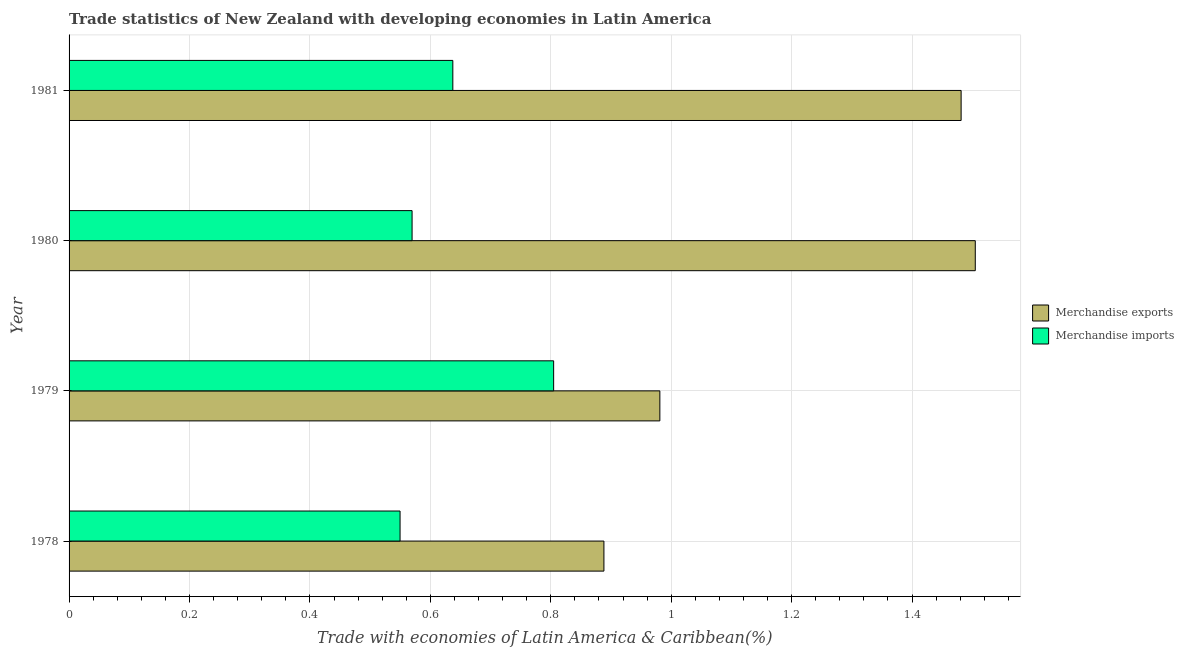Are the number of bars per tick equal to the number of legend labels?
Your response must be concise. Yes. How many bars are there on the 2nd tick from the bottom?
Provide a short and direct response. 2. What is the label of the 2nd group of bars from the top?
Your response must be concise. 1980. What is the merchandise imports in 1978?
Keep it short and to the point. 0.55. Across all years, what is the maximum merchandise imports?
Ensure brevity in your answer.  0.8. Across all years, what is the minimum merchandise imports?
Your answer should be very brief. 0.55. In which year was the merchandise exports maximum?
Ensure brevity in your answer.  1980. In which year was the merchandise imports minimum?
Your answer should be compact. 1978. What is the total merchandise imports in the graph?
Offer a very short reply. 2.56. What is the difference between the merchandise imports in 1978 and that in 1980?
Your answer should be compact. -0.02. What is the difference between the merchandise imports in 1979 and the merchandise exports in 1978?
Keep it short and to the point. -0.08. What is the average merchandise exports per year?
Ensure brevity in your answer.  1.21. In the year 1981, what is the difference between the merchandise exports and merchandise imports?
Provide a succinct answer. 0.84. What is the ratio of the merchandise imports in 1979 to that in 1981?
Offer a terse response. 1.26. Is the merchandise exports in 1978 less than that in 1981?
Give a very brief answer. Yes. Is the difference between the merchandise imports in 1978 and 1981 greater than the difference between the merchandise exports in 1978 and 1981?
Keep it short and to the point. Yes. What is the difference between the highest and the second highest merchandise imports?
Offer a terse response. 0.17. What is the difference between the highest and the lowest merchandise exports?
Your response must be concise. 0.62. What does the 1st bar from the top in 1980 represents?
Ensure brevity in your answer.  Merchandise imports. How many bars are there?
Your answer should be very brief. 8. Are all the bars in the graph horizontal?
Make the answer very short. Yes. How many years are there in the graph?
Your answer should be very brief. 4. What is the difference between two consecutive major ticks on the X-axis?
Provide a short and direct response. 0.2. Are the values on the major ticks of X-axis written in scientific E-notation?
Your answer should be very brief. No. Where does the legend appear in the graph?
Ensure brevity in your answer.  Center right. What is the title of the graph?
Give a very brief answer. Trade statistics of New Zealand with developing economies in Latin America. Does "GDP at market prices" appear as one of the legend labels in the graph?
Your answer should be very brief. No. What is the label or title of the X-axis?
Your response must be concise. Trade with economies of Latin America & Caribbean(%). What is the Trade with economies of Latin America & Caribbean(%) in Merchandise exports in 1978?
Your answer should be very brief. 0.89. What is the Trade with economies of Latin America & Caribbean(%) of Merchandise imports in 1978?
Ensure brevity in your answer.  0.55. What is the Trade with economies of Latin America & Caribbean(%) of Merchandise exports in 1979?
Offer a very short reply. 0.98. What is the Trade with economies of Latin America & Caribbean(%) in Merchandise imports in 1979?
Your answer should be very brief. 0.8. What is the Trade with economies of Latin America & Caribbean(%) of Merchandise exports in 1980?
Provide a succinct answer. 1.5. What is the Trade with economies of Latin America & Caribbean(%) of Merchandise imports in 1980?
Your response must be concise. 0.57. What is the Trade with economies of Latin America & Caribbean(%) of Merchandise exports in 1981?
Give a very brief answer. 1.48. What is the Trade with economies of Latin America & Caribbean(%) in Merchandise imports in 1981?
Make the answer very short. 0.64. Across all years, what is the maximum Trade with economies of Latin America & Caribbean(%) in Merchandise exports?
Give a very brief answer. 1.5. Across all years, what is the maximum Trade with economies of Latin America & Caribbean(%) in Merchandise imports?
Offer a terse response. 0.8. Across all years, what is the minimum Trade with economies of Latin America & Caribbean(%) of Merchandise exports?
Keep it short and to the point. 0.89. Across all years, what is the minimum Trade with economies of Latin America & Caribbean(%) of Merchandise imports?
Offer a very short reply. 0.55. What is the total Trade with economies of Latin America & Caribbean(%) in Merchandise exports in the graph?
Offer a terse response. 4.86. What is the total Trade with economies of Latin America & Caribbean(%) in Merchandise imports in the graph?
Give a very brief answer. 2.56. What is the difference between the Trade with economies of Latin America & Caribbean(%) of Merchandise exports in 1978 and that in 1979?
Offer a very short reply. -0.09. What is the difference between the Trade with economies of Latin America & Caribbean(%) of Merchandise imports in 1978 and that in 1979?
Offer a very short reply. -0.26. What is the difference between the Trade with economies of Latin America & Caribbean(%) in Merchandise exports in 1978 and that in 1980?
Provide a succinct answer. -0.62. What is the difference between the Trade with economies of Latin America & Caribbean(%) in Merchandise imports in 1978 and that in 1980?
Keep it short and to the point. -0.02. What is the difference between the Trade with economies of Latin America & Caribbean(%) in Merchandise exports in 1978 and that in 1981?
Your answer should be very brief. -0.59. What is the difference between the Trade with economies of Latin America & Caribbean(%) in Merchandise imports in 1978 and that in 1981?
Ensure brevity in your answer.  -0.09. What is the difference between the Trade with economies of Latin America & Caribbean(%) of Merchandise exports in 1979 and that in 1980?
Make the answer very short. -0.52. What is the difference between the Trade with economies of Latin America & Caribbean(%) of Merchandise imports in 1979 and that in 1980?
Keep it short and to the point. 0.24. What is the difference between the Trade with economies of Latin America & Caribbean(%) of Merchandise exports in 1979 and that in 1981?
Offer a terse response. -0.5. What is the difference between the Trade with economies of Latin America & Caribbean(%) of Merchandise imports in 1979 and that in 1981?
Provide a short and direct response. 0.17. What is the difference between the Trade with economies of Latin America & Caribbean(%) of Merchandise exports in 1980 and that in 1981?
Offer a very short reply. 0.02. What is the difference between the Trade with economies of Latin America & Caribbean(%) in Merchandise imports in 1980 and that in 1981?
Your answer should be very brief. -0.07. What is the difference between the Trade with economies of Latin America & Caribbean(%) in Merchandise exports in 1978 and the Trade with economies of Latin America & Caribbean(%) in Merchandise imports in 1979?
Make the answer very short. 0.08. What is the difference between the Trade with economies of Latin America & Caribbean(%) in Merchandise exports in 1978 and the Trade with economies of Latin America & Caribbean(%) in Merchandise imports in 1980?
Your answer should be very brief. 0.32. What is the difference between the Trade with economies of Latin America & Caribbean(%) in Merchandise exports in 1978 and the Trade with economies of Latin America & Caribbean(%) in Merchandise imports in 1981?
Make the answer very short. 0.25. What is the difference between the Trade with economies of Latin America & Caribbean(%) in Merchandise exports in 1979 and the Trade with economies of Latin America & Caribbean(%) in Merchandise imports in 1980?
Your response must be concise. 0.41. What is the difference between the Trade with economies of Latin America & Caribbean(%) of Merchandise exports in 1979 and the Trade with economies of Latin America & Caribbean(%) of Merchandise imports in 1981?
Give a very brief answer. 0.34. What is the difference between the Trade with economies of Latin America & Caribbean(%) of Merchandise exports in 1980 and the Trade with economies of Latin America & Caribbean(%) of Merchandise imports in 1981?
Ensure brevity in your answer.  0.87. What is the average Trade with economies of Latin America & Caribbean(%) of Merchandise exports per year?
Ensure brevity in your answer.  1.21. What is the average Trade with economies of Latin America & Caribbean(%) of Merchandise imports per year?
Offer a terse response. 0.64. In the year 1978, what is the difference between the Trade with economies of Latin America & Caribbean(%) of Merchandise exports and Trade with economies of Latin America & Caribbean(%) of Merchandise imports?
Give a very brief answer. 0.34. In the year 1979, what is the difference between the Trade with economies of Latin America & Caribbean(%) in Merchandise exports and Trade with economies of Latin America & Caribbean(%) in Merchandise imports?
Your response must be concise. 0.18. In the year 1980, what is the difference between the Trade with economies of Latin America & Caribbean(%) in Merchandise exports and Trade with economies of Latin America & Caribbean(%) in Merchandise imports?
Keep it short and to the point. 0.94. In the year 1981, what is the difference between the Trade with economies of Latin America & Caribbean(%) of Merchandise exports and Trade with economies of Latin America & Caribbean(%) of Merchandise imports?
Ensure brevity in your answer.  0.84. What is the ratio of the Trade with economies of Latin America & Caribbean(%) of Merchandise exports in 1978 to that in 1979?
Offer a terse response. 0.91. What is the ratio of the Trade with economies of Latin America & Caribbean(%) in Merchandise imports in 1978 to that in 1979?
Offer a very short reply. 0.68. What is the ratio of the Trade with economies of Latin America & Caribbean(%) in Merchandise exports in 1978 to that in 1980?
Provide a short and direct response. 0.59. What is the ratio of the Trade with economies of Latin America & Caribbean(%) of Merchandise imports in 1978 to that in 1980?
Give a very brief answer. 0.96. What is the ratio of the Trade with economies of Latin America & Caribbean(%) in Merchandise exports in 1978 to that in 1981?
Ensure brevity in your answer.  0.6. What is the ratio of the Trade with economies of Latin America & Caribbean(%) of Merchandise imports in 1978 to that in 1981?
Your answer should be compact. 0.86. What is the ratio of the Trade with economies of Latin America & Caribbean(%) in Merchandise exports in 1979 to that in 1980?
Your answer should be very brief. 0.65. What is the ratio of the Trade with economies of Latin America & Caribbean(%) in Merchandise imports in 1979 to that in 1980?
Give a very brief answer. 1.41. What is the ratio of the Trade with economies of Latin America & Caribbean(%) in Merchandise exports in 1979 to that in 1981?
Provide a short and direct response. 0.66. What is the ratio of the Trade with economies of Latin America & Caribbean(%) of Merchandise imports in 1979 to that in 1981?
Your response must be concise. 1.26. What is the ratio of the Trade with economies of Latin America & Caribbean(%) of Merchandise exports in 1980 to that in 1981?
Provide a succinct answer. 1.02. What is the ratio of the Trade with economies of Latin America & Caribbean(%) of Merchandise imports in 1980 to that in 1981?
Provide a succinct answer. 0.89. What is the difference between the highest and the second highest Trade with economies of Latin America & Caribbean(%) of Merchandise exports?
Offer a terse response. 0.02. What is the difference between the highest and the second highest Trade with economies of Latin America & Caribbean(%) in Merchandise imports?
Your response must be concise. 0.17. What is the difference between the highest and the lowest Trade with economies of Latin America & Caribbean(%) of Merchandise exports?
Offer a very short reply. 0.62. What is the difference between the highest and the lowest Trade with economies of Latin America & Caribbean(%) in Merchandise imports?
Offer a terse response. 0.26. 